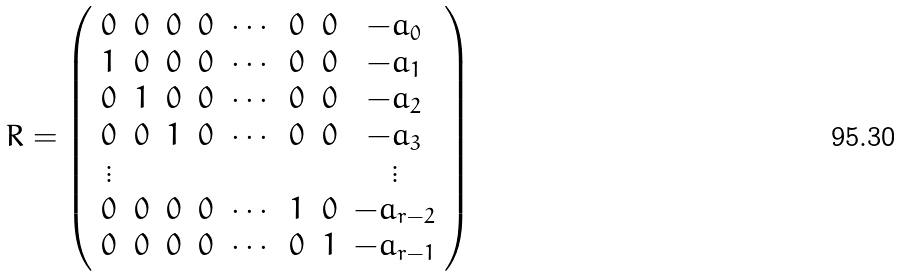<formula> <loc_0><loc_0><loc_500><loc_500>R = \left ( \begin{array} { c c c c c c c c } 0 & 0 & 0 & 0 & \cdots & 0 & 0 & - a _ { 0 } \\ 1 & 0 & 0 & 0 & \cdots & 0 & 0 & - a _ { 1 } \\ 0 & 1 & 0 & 0 & \cdots & 0 & 0 & - a _ { 2 } \\ 0 & 0 & 1 & 0 & \cdots & 0 & 0 & - a _ { 3 } \\ \vdots & & & & & & & \vdots \\ 0 & 0 & 0 & 0 & \cdots & 1 & 0 & - a _ { r - 2 } \\ 0 & 0 & 0 & 0 & \cdots & 0 & 1 & - a _ { r - 1 } \end{array} \right )</formula> 